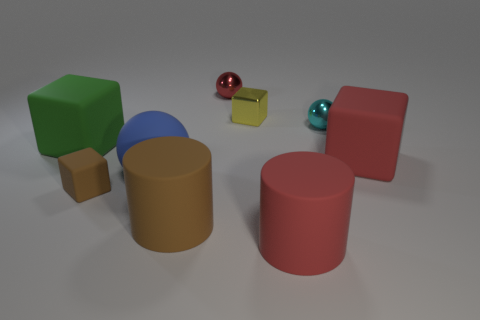What number of objects are red rubber things that are behind the large sphere or things on the right side of the rubber sphere?
Your answer should be compact. 6. Are there more small red spheres than rubber cubes?
Keep it short and to the point. No. What color is the tiny cube behind the blue thing?
Ensure brevity in your answer.  Yellow. Is the blue thing the same shape as the green thing?
Give a very brief answer. No. What is the color of the cube that is both on the right side of the small brown matte object and in front of the tiny yellow thing?
Offer a terse response. Red. Is the size of the thing in front of the brown matte cylinder the same as the thing left of the small brown cube?
Your answer should be compact. Yes. How many objects are either cubes in front of the big blue matte object or blue metallic cylinders?
Provide a short and direct response. 1. What is the material of the cyan sphere?
Provide a succinct answer. Metal. Do the cyan ball and the red metal sphere have the same size?
Your response must be concise. Yes. How many cylinders are small brown objects or big matte things?
Offer a terse response. 2. 